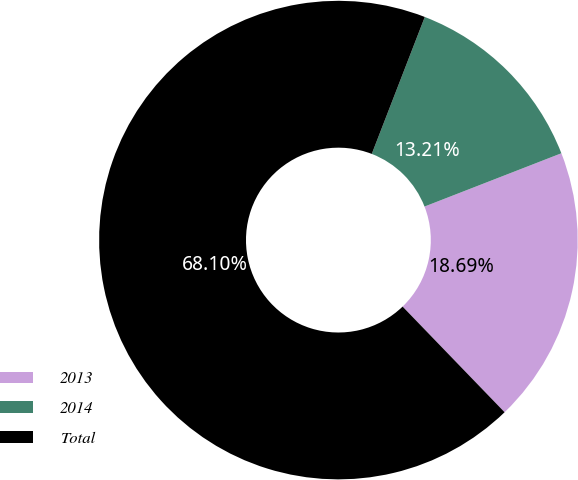<chart> <loc_0><loc_0><loc_500><loc_500><pie_chart><fcel>2013<fcel>2014<fcel>Total<nl><fcel>18.69%<fcel>13.21%<fcel>68.1%<nl></chart> 